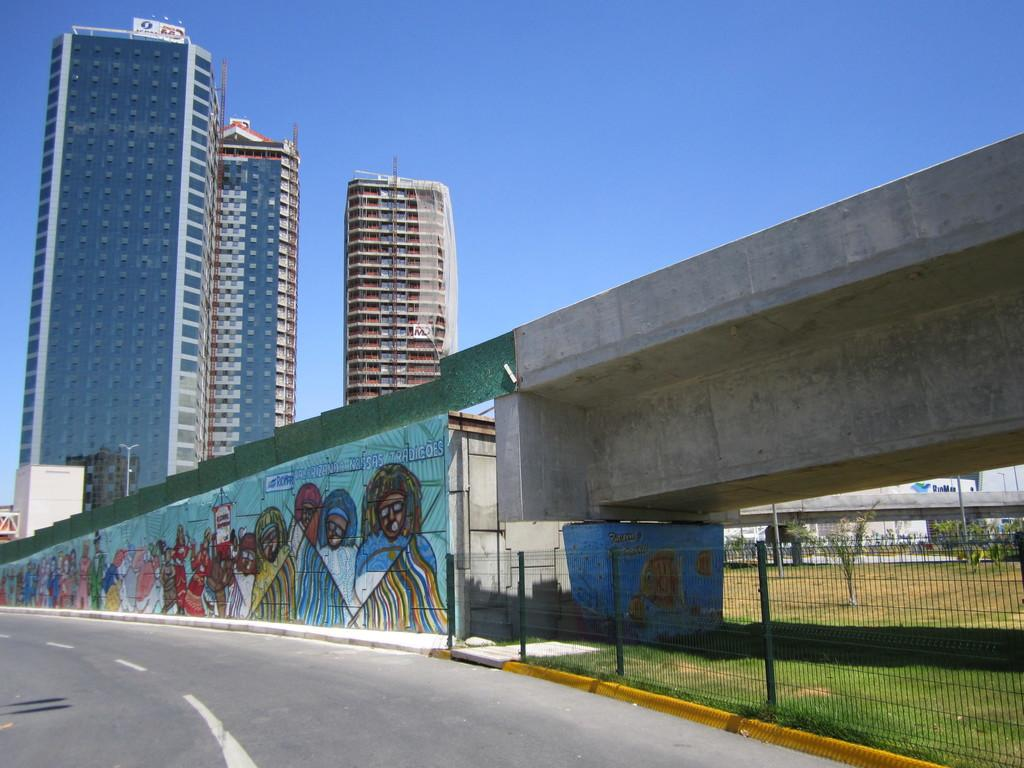What is the main feature of the image? There is a road in the image. What structure is near the road? There is a bridge near the road. What is on the bridge? There is graffiti on the bridge. What type of fencing is present in the image? There is mesh fencing in the image. What can be seen in the background of the image? There are buildings and the sky visible in the background of the image. What type of yak can be seen grazing on the side of the road in the image? There are no yaks present in the image; it features a road, a bridge, graffiti, mesh fencing, buildings, and the sky. What is the nation of origin for the graffiti on the bridge? The image does not provide information about the nation of origin for the graffiti on the bridge. 